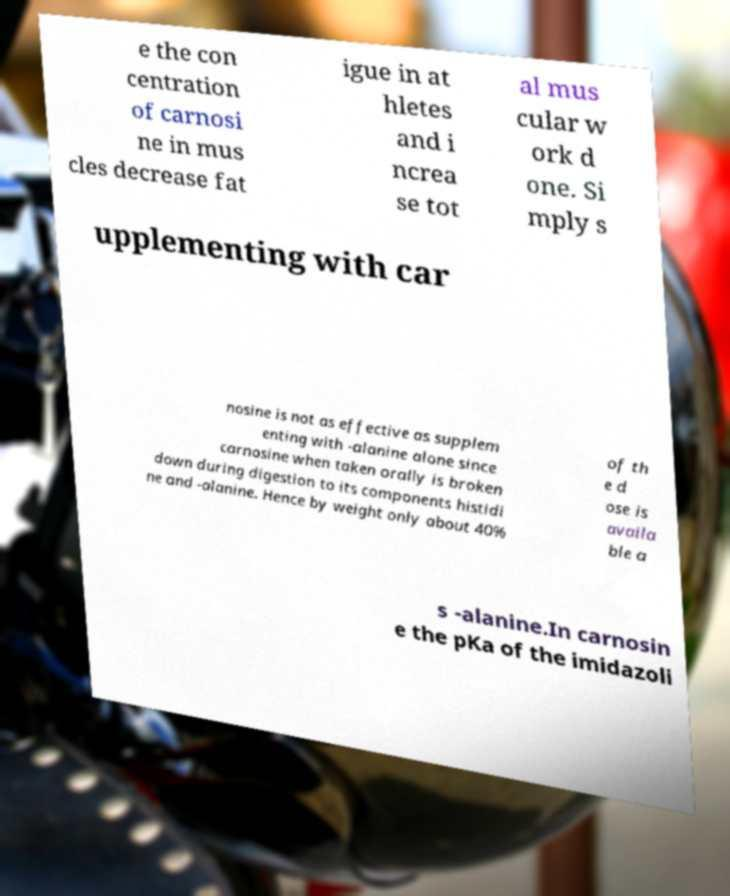Could you assist in decoding the text presented in this image and type it out clearly? e the con centration of carnosi ne in mus cles decrease fat igue in at hletes and i ncrea se tot al mus cular w ork d one. Si mply s upplementing with car nosine is not as effective as supplem enting with -alanine alone since carnosine when taken orally is broken down during digestion to its components histidi ne and -alanine. Hence by weight only about 40% of th e d ose is availa ble a s -alanine.In carnosin e the pKa of the imidazoli 